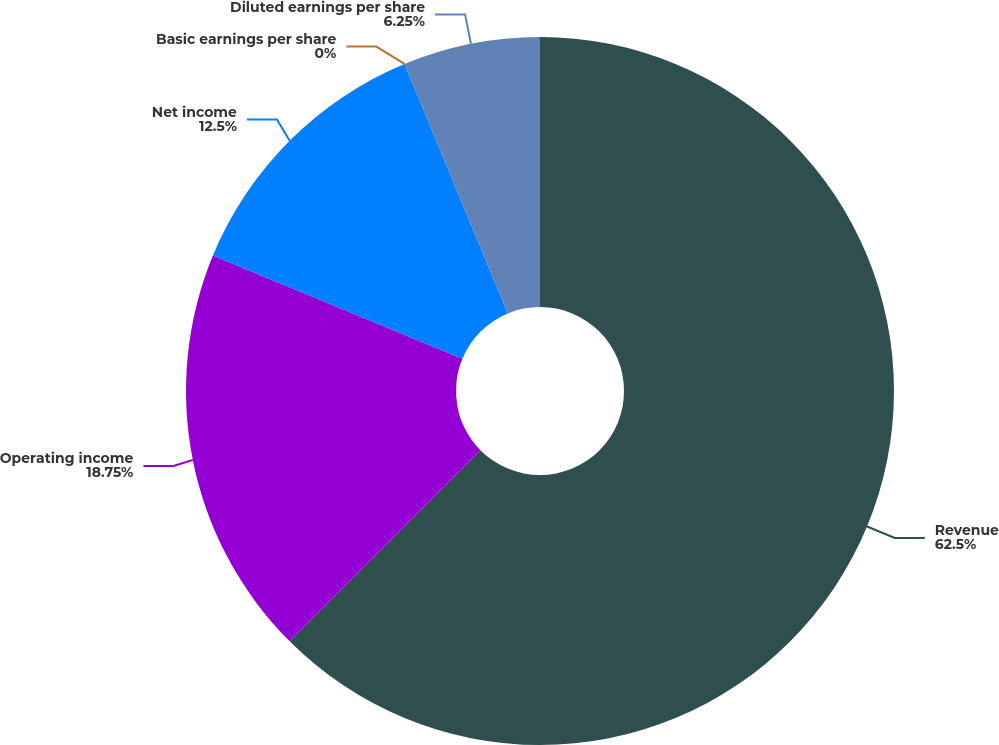Convert chart to OTSL. <chart><loc_0><loc_0><loc_500><loc_500><pie_chart><fcel>Revenue<fcel>Operating income<fcel>Net income<fcel>Basic earnings per share<fcel>Diluted earnings per share<nl><fcel>62.5%<fcel>18.75%<fcel>12.5%<fcel>0.0%<fcel>6.25%<nl></chart> 